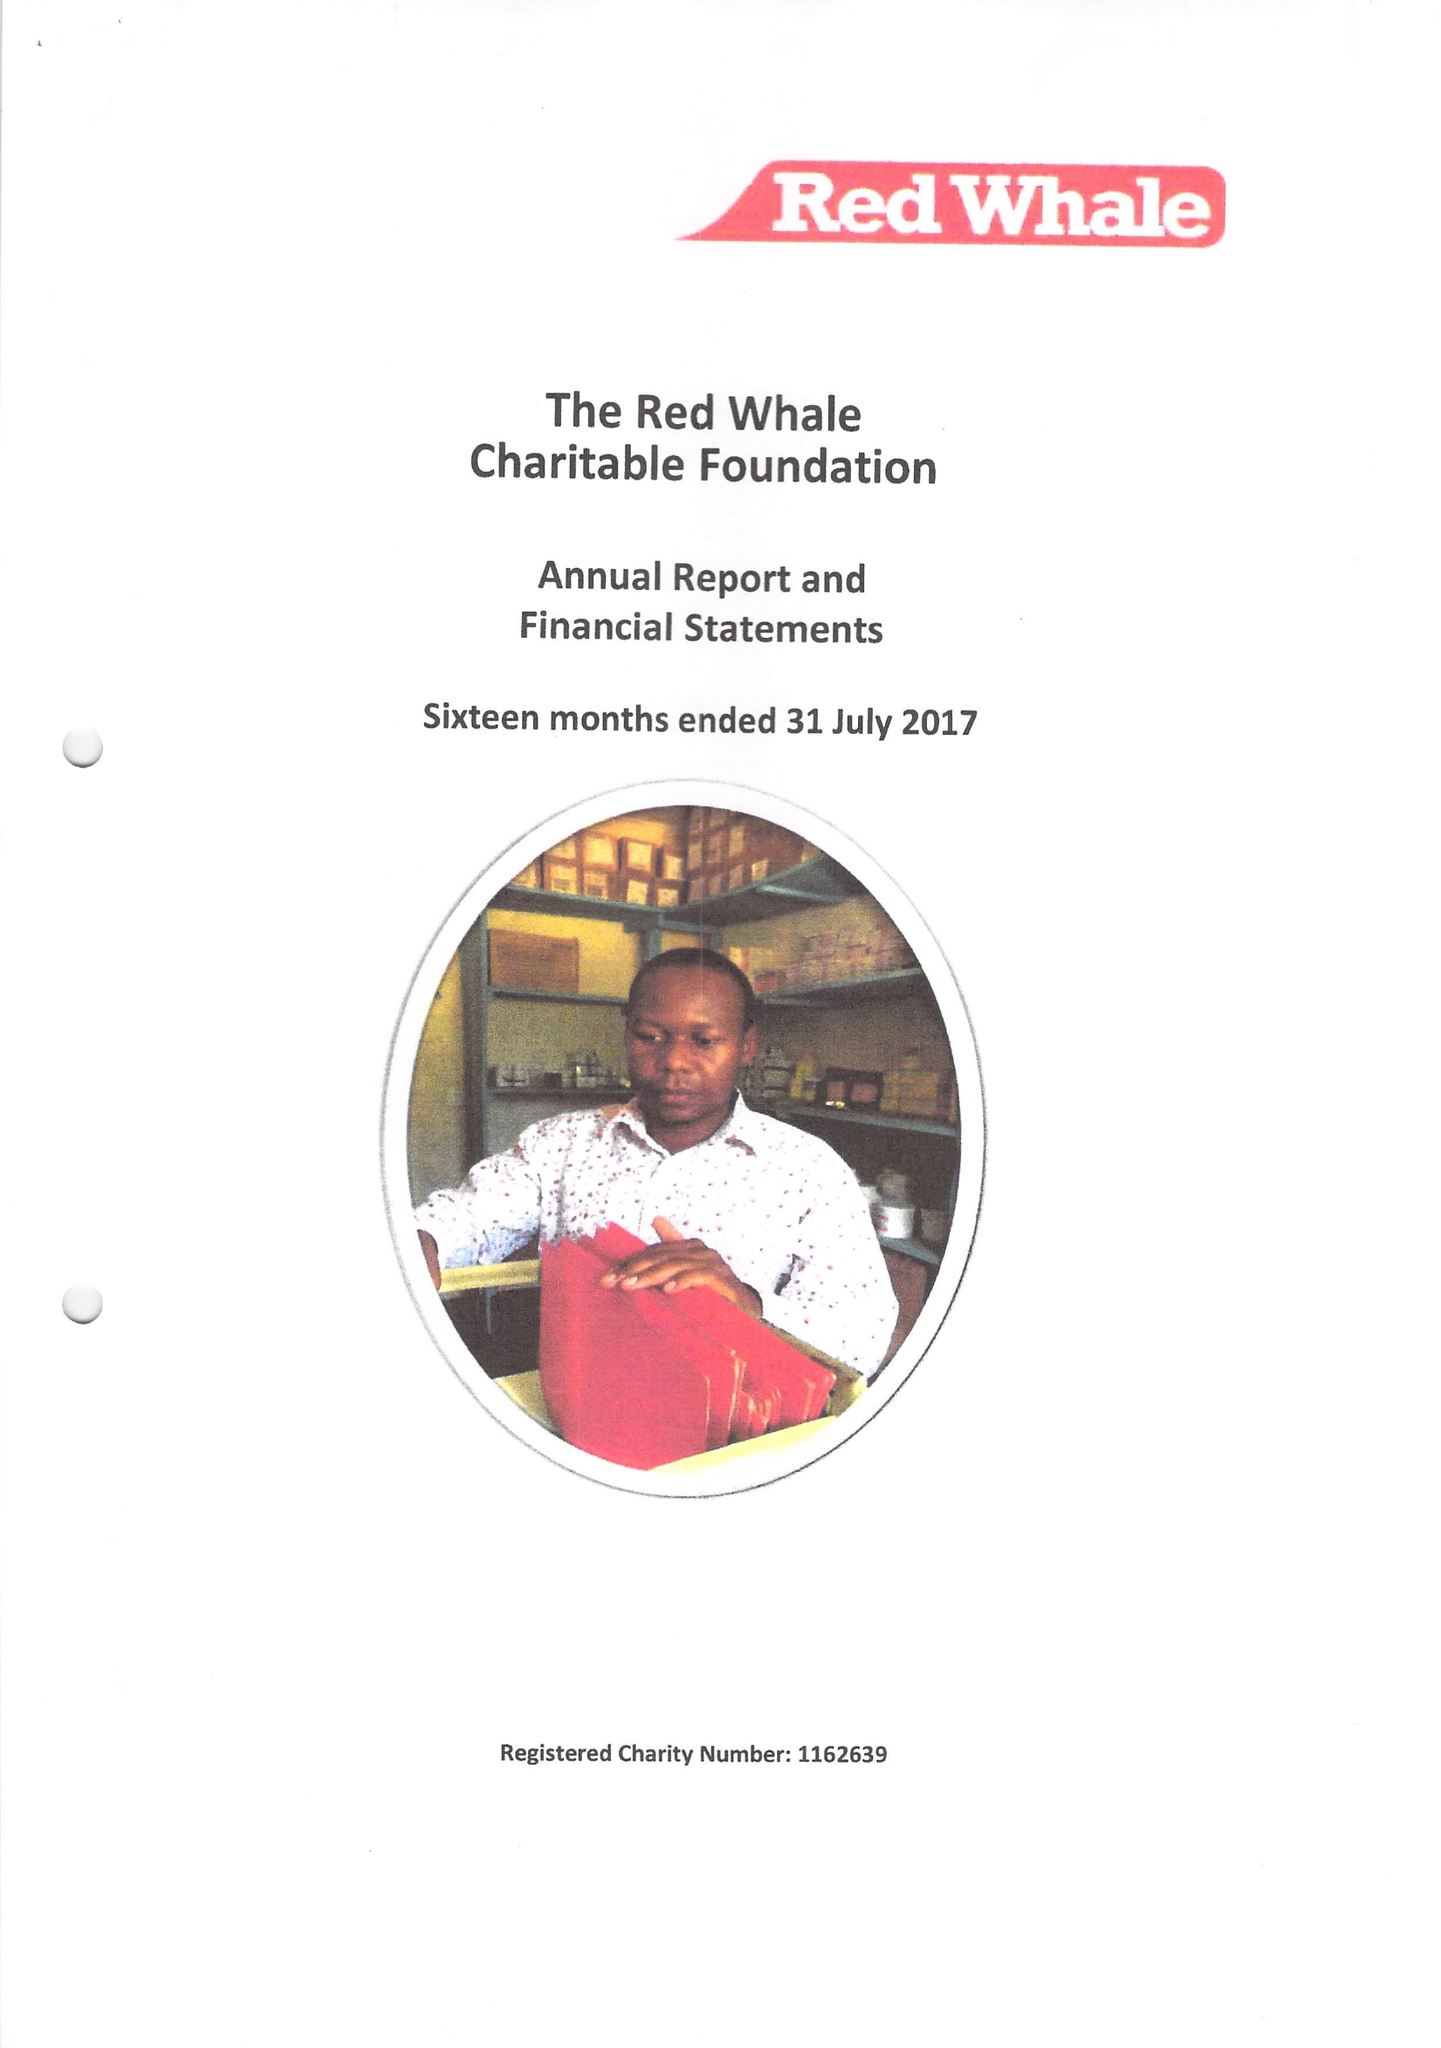What is the value for the report_date?
Answer the question using a single word or phrase. 2017-07-31 